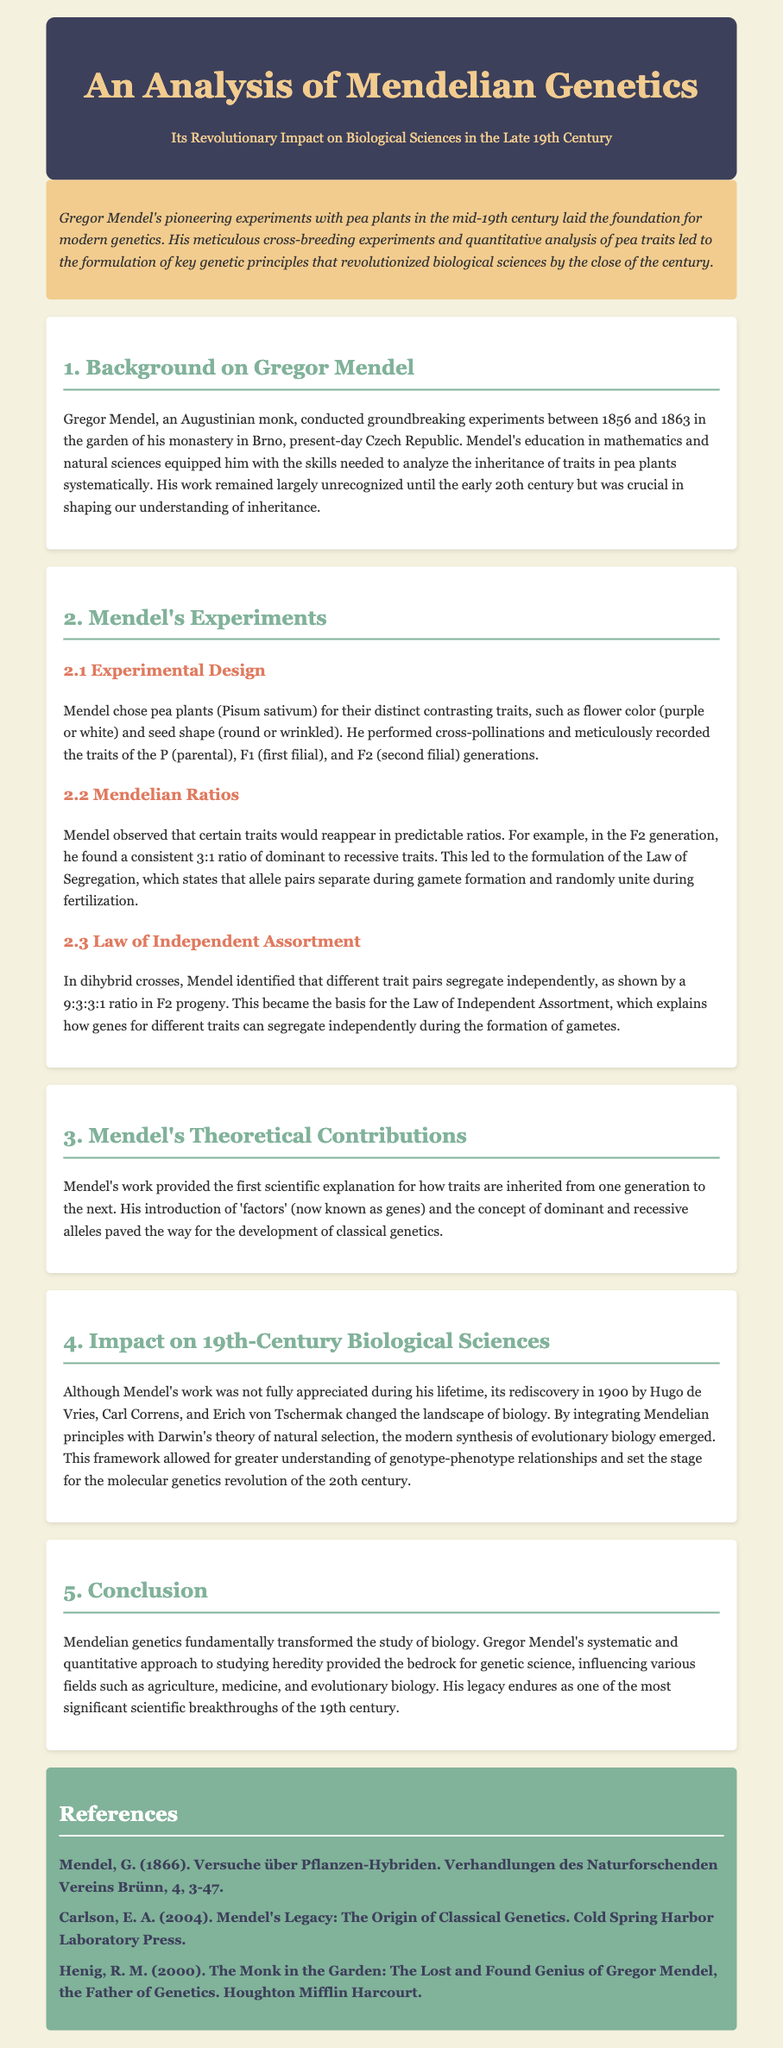What years did Mendel conduct his experiments? The document states that Mendel conducted his experiments between 1856 and 1863.
Answer: 1856-1863 What trait ratios did Mendel observe in the F2 generation? The document mentions a consistent 3:1 ratio of dominant to recessive traits in the F2 generation.
Answer: 3:1 What is the name of the monk who conducted the groundbreaking experiments? The document identifies Gregor Mendel as the monk who conducted the experiments.
Answer: Gregor Mendel What principle explains that different trait pairs segregate independently? The document notes the principle as the Law of Independent Assortment.
Answer: Law of Independent Assortment In which country did Mendel conduct his experiments? The document specifies that Mendel conducted his experiments in present-day Czech Republic.
Answer: Czech Republic What impact did Mendel's work have on 20th-century Genetics? The document states that Mendel's work set the stage for the molecular genetics revolution of the 20th century.
Answer: Molecular genetics revolution Who rediscovered Mendel's work in 1900? The document lists Hugo de Vries, Carl Correns, and Erich von Tschermak as the individuals who rediscovered Mendel's work.
Answer: Hugo de Vries, Carl Correns, Erich von Tschermak What type of plants did Mendel use in his experiments? The document states that Mendel used pea plants (Pisum sativum) in his experiments.
Answer: Pea plants What concept did Mendel introduce that relates to dominant and recessive traits? The document says Mendel introduced the concept of 'factors', now known as genes.
Answer: Factors (genes) 